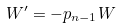Convert formula to latex. <formula><loc_0><loc_0><loc_500><loc_500>W ^ { \prime } = - p _ { n - 1 } W</formula> 